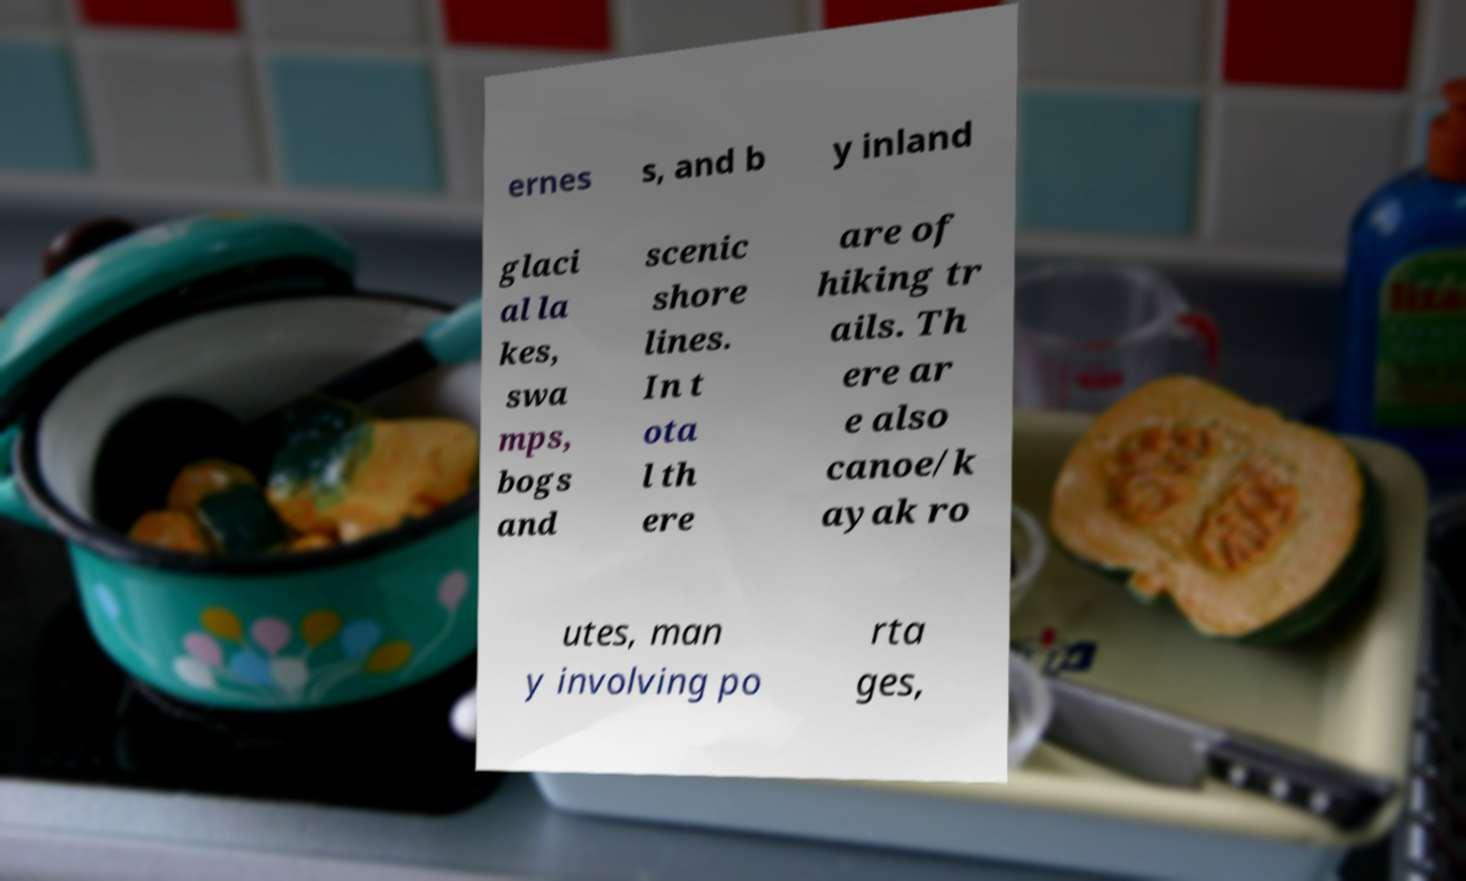Can you accurately transcribe the text from the provided image for me? ernes s, and b y inland glaci al la kes, swa mps, bogs and scenic shore lines. In t ota l th ere are of hiking tr ails. Th ere ar e also canoe/k ayak ro utes, man y involving po rta ges, 